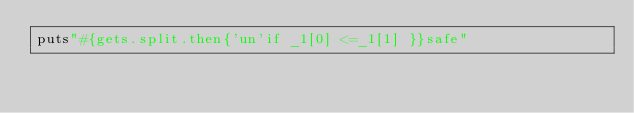Convert code to text. <code><loc_0><loc_0><loc_500><loc_500><_Ruby_>puts"#{gets.split.then{'un'if _1[0] <=_1[1] }}safe"</code> 